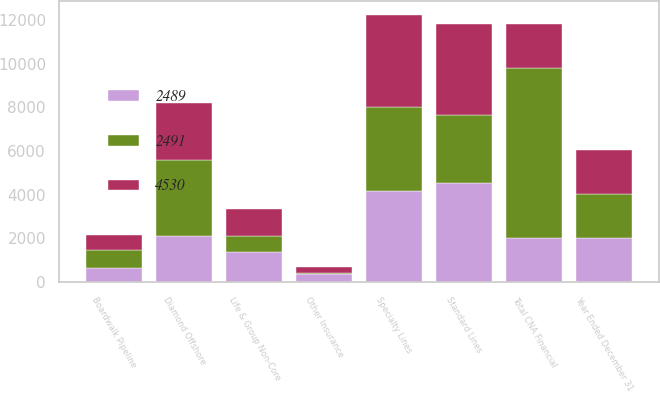Convert chart to OTSL. <chart><loc_0><loc_0><loc_500><loc_500><stacked_bar_chart><ecel><fcel>Year Ended December 31<fcel>Standard Lines<fcel>Specialty Lines<fcel>Life & Group Non-Core<fcel>Other Insurance<fcel>Total CNA Financial<fcel>Diamond Offshore<fcel>Boardwalk Pipeline<nl><fcel>2491<fcel>2008<fcel>3141<fcel>3867<fcel>761<fcel>30<fcel>7799<fcel>3486<fcel>848<nl><fcel>4530<fcel>2007<fcel>4155<fcel>4212<fcel>1220<fcel>299<fcel>2007.5<fcel>2617<fcel>671<nl><fcel>2489<fcel>2006<fcel>4513<fcel>4153<fcel>1355<fcel>361<fcel>2007.5<fcel>2102<fcel>618<nl></chart> 